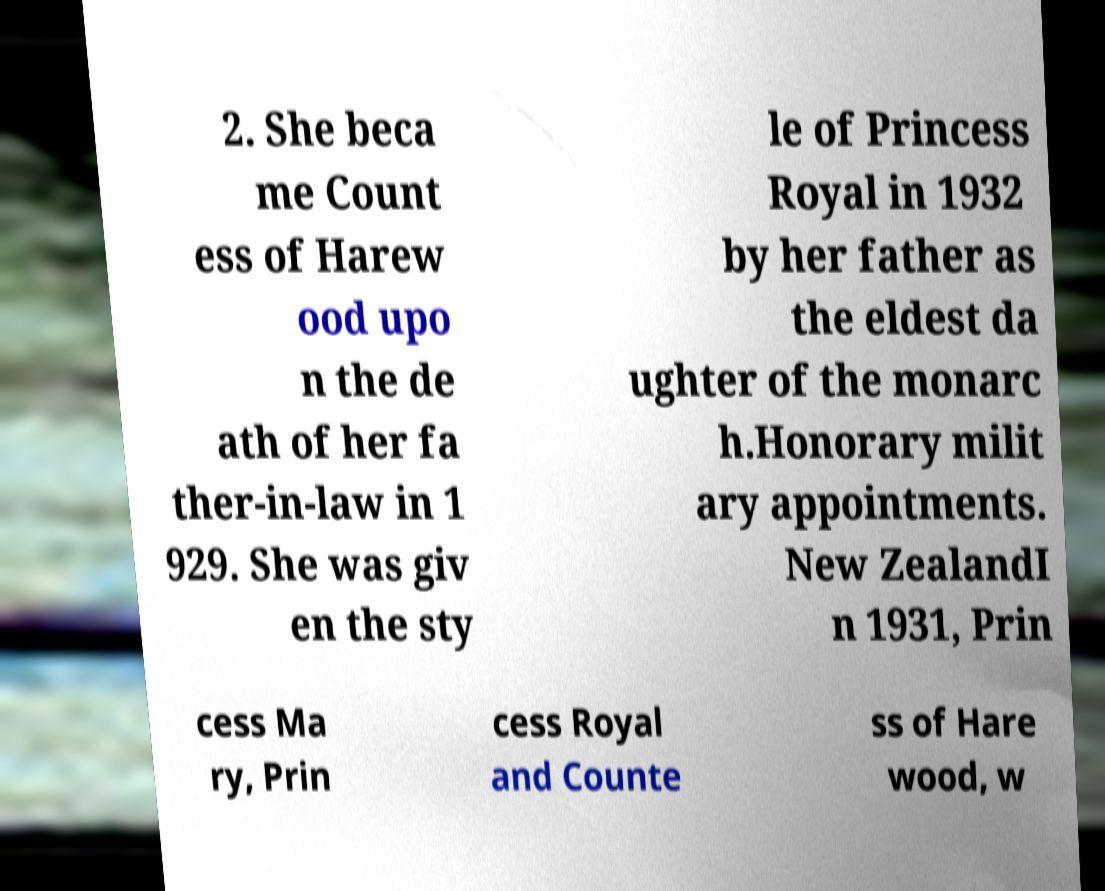Could you assist in decoding the text presented in this image and type it out clearly? 2. She beca me Count ess of Harew ood upo n the de ath of her fa ther-in-law in 1 929. She was giv en the sty le of Princess Royal in 1932 by her father as the eldest da ughter of the monarc h.Honorary milit ary appointments. New ZealandI n 1931, Prin cess Ma ry, Prin cess Royal and Counte ss of Hare wood, w 